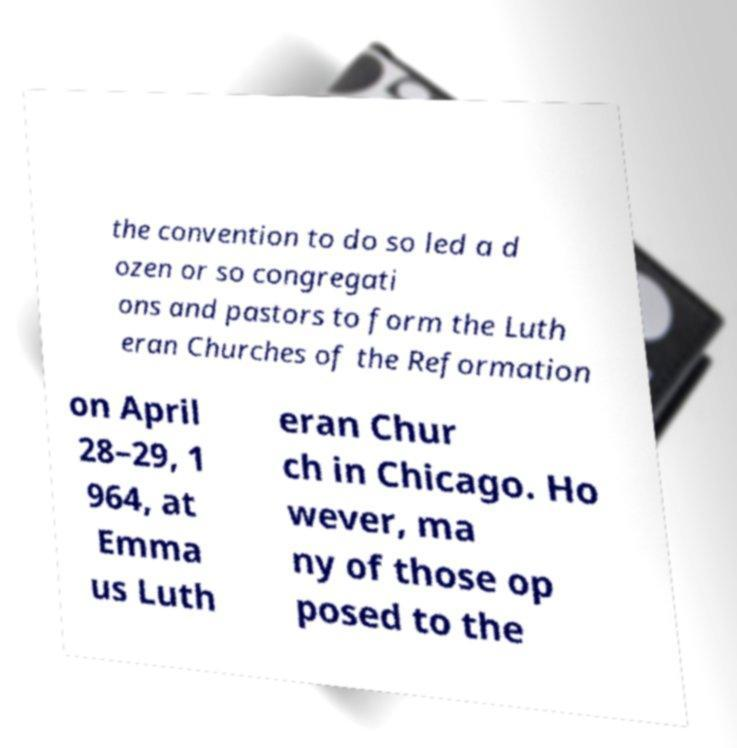For documentation purposes, I need the text within this image transcribed. Could you provide that? the convention to do so led a d ozen or so congregati ons and pastors to form the Luth eran Churches of the Reformation on April 28–29, 1 964, at Emma us Luth eran Chur ch in Chicago. Ho wever, ma ny of those op posed to the 